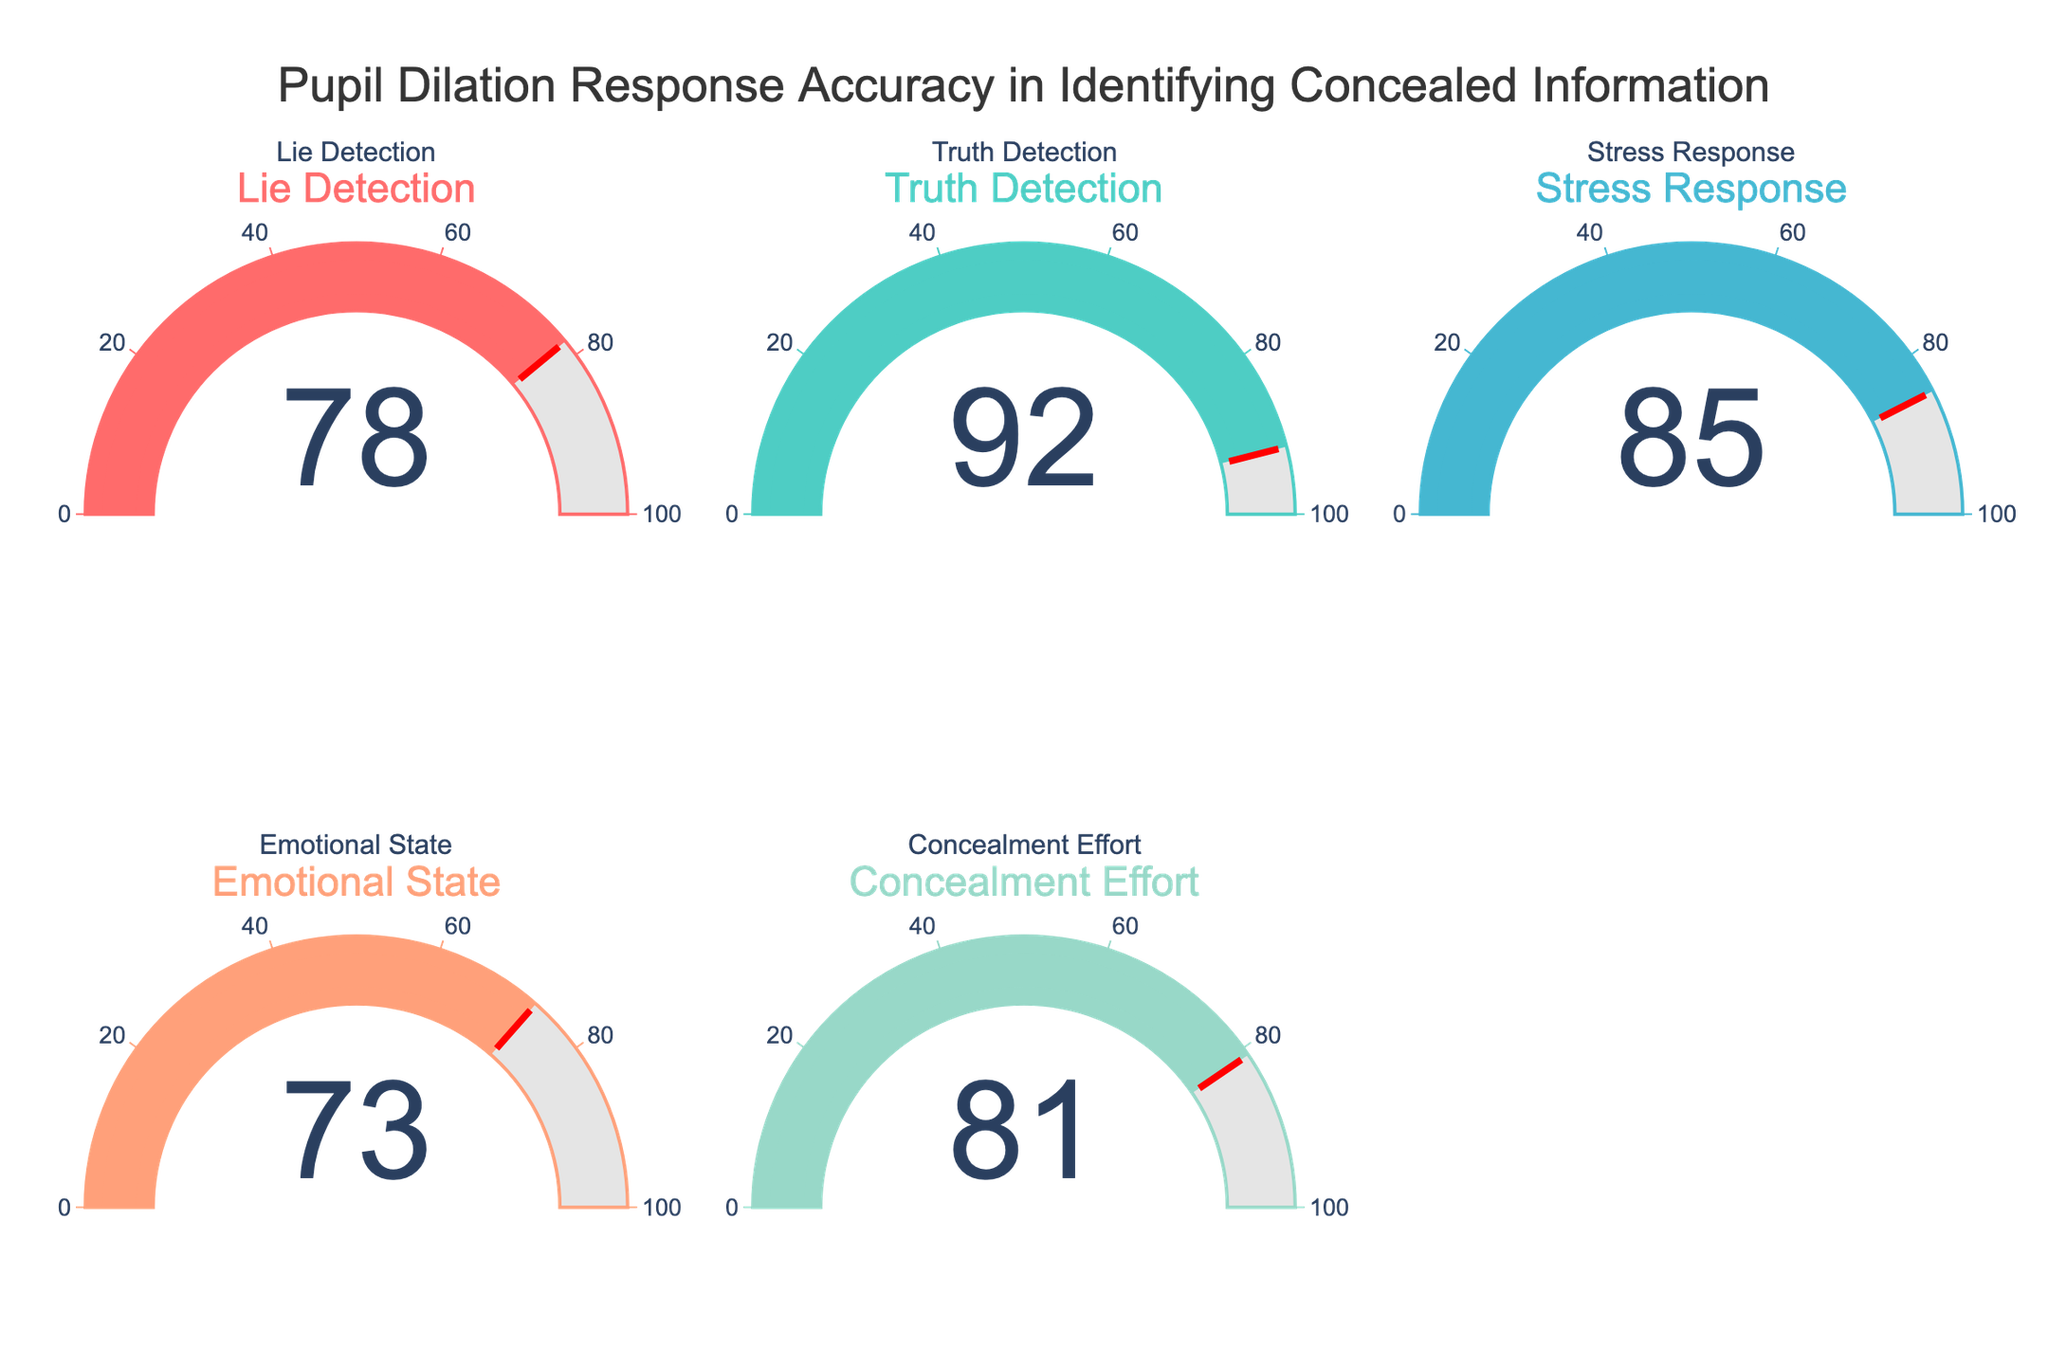What's the highest value shown on the gauges? To find the highest value, look at the number displayed on each gauge. The values are 78, 92, 85, 73, and 81. The highest number is 92.
Answer: 92 Which metric has the lowest accuracy? To determine the lowest accuracy, compare the values displayed on all gauges. The values are 78, 92, 85, 73, and 81. The lowest number is 73, labeled 'Emotional State.'
Answer: Emotional State What is the combined accuracy of Lie Detection and Truth Detection? Add the values of 'Lie Detection' and 'Truth Detection'. The values are 78 and 92, respectively. 78 + 92 = 170.
Answer: 170 How many gauges have an accuracy value above 80? Count the number of gauges with values greater than 80. The values are 78, 92, 85, 73, and 81. The gauges with values above 80 are 92, 85, and 81. So, there are 3 gauges.
Answer: 3 Which two metrics' accuracies differ the most? To find the greatest difference, subtract the smallest value from the largest value among the metrics. The values are 78, 92, 85, 73, and 81. The largest value is 92 (Truth Detection), and the smallest is 73 (Emotional State). So, the greatest difference is 92 - 73 = 19.
Answer: Truth Detection and Emotional State What is the average accuracy across all metrics? To find the average, sum all the accuracy values and divide by the number of metrics. The values are 78, 92, 85, 73, and 81. Sum = 78 + 92 + 85 + 73 + 81 = 409. Number of metrics = 5. Average = 409 / 5 = 81.8.
Answer: 81.8 Which metric has the closest accuracy to Concealment Effort? To find the closest value to Concealment Effort (81), compare 81 to each of the other values (78, 92, 85, 73). The closest value is 78, which is 3 units away.
Answer: Lie Detection Is the accuracy for Stress Response greater than the average accuracy across all metrics? First, calculate the average accuracy, which is 81.8. Then, compare it with the accuracy for Stress Response, which is 85. Since 85 is greater than 81.8, the answer is yes.
Answer: Yes 